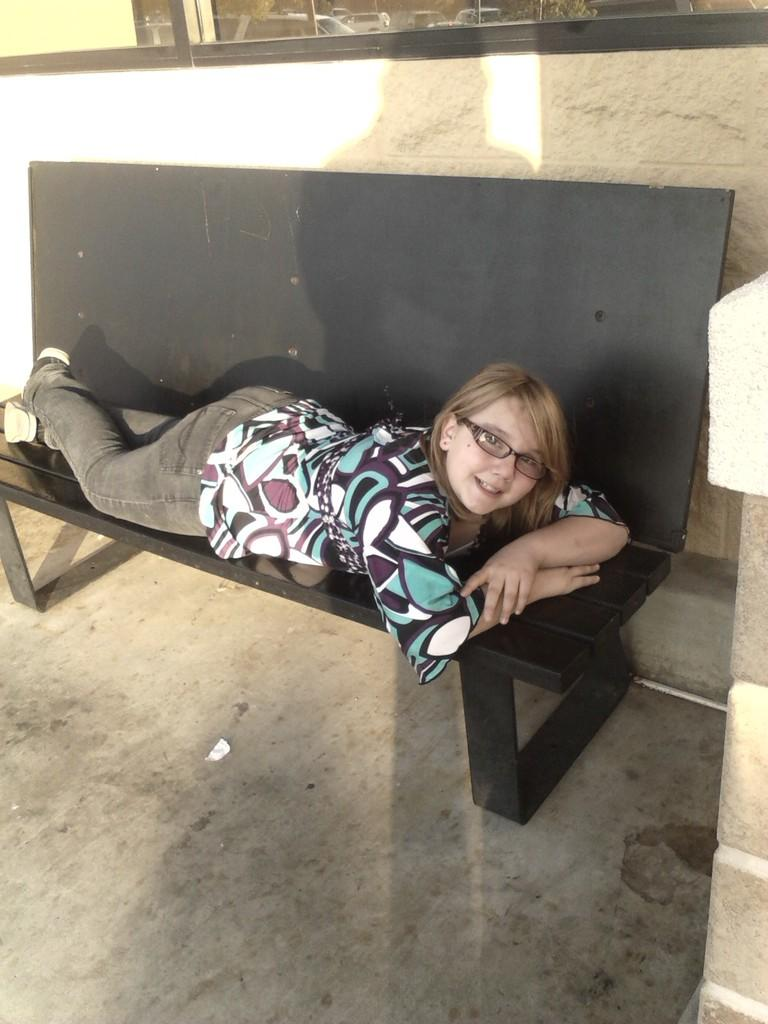Who is the main subject in the image? There is a woman in the image. What is the woman doing in the image? The woman is laying on a black color bench. What is the woman wearing in the image? The woman is wearing spectacles. What is the woman's facial expression in the image? The woman is smiling. What can be seen in the background of the image? There is a wall in the background of the image. What type of quartz can be seen in the woman's hand in the image? There is no quartz present in the image; the woman is not holding any quartz. What kind of bone is visible in the woman's hair in the image? There is no bone present in the image; the woman's hair does not contain any bones. 